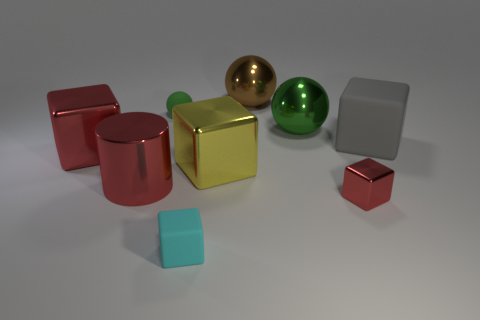Subtract all gray blocks. How many blocks are left? 4 Subtract all big red cubes. How many cubes are left? 4 Subtract all green cubes. Subtract all brown cylinders. How many cubes are left? 5 Add 1 tiny red metal cylinders. How many objects exist? 10 Subtract all cylinders. How many objects are left? 8 Add 6 green metallic objects. How many green metallic objects are left? 7 Add 7 big red metal objects. How many big red metal objects exist? 9 Subtract 0 green blocks. How many objects are left? 9 Subtract all small green matte cylinders. Subtract all tiny cyan matte cubes. How many objects are left? 8 